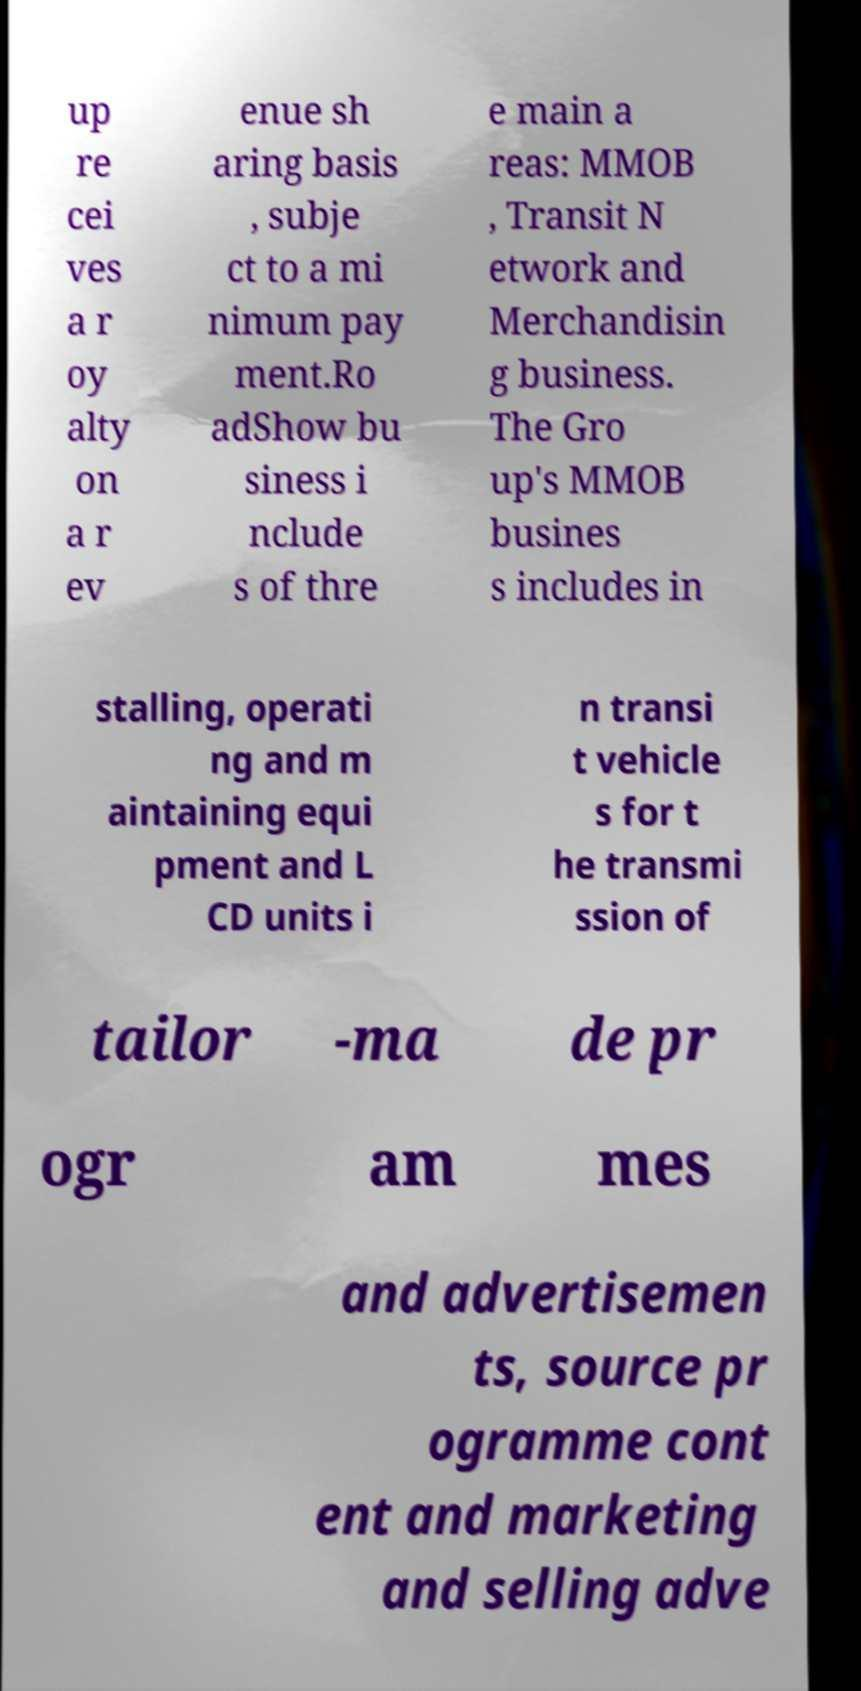Can you read and provide the text displayed in the image?This photo seems to have some interesting text. Can you extract and type it out for me? up re cei ves a r oy alty on a r ev enue sh aring basis , subje ct to a mi nimum pay ment.Ro adShow bu siness i nclude s of thre e main a reas: MMOB , Transit N etwork and Merchandisin g business. The Gro up's MMOB busines s includes in stalling, operati ng and m aintaining equi pment and L CD units i n transi t vehicle s for t he transmi ssion of tailor -ma de pr ogr am mes and advertisemen ts, source pr ogramme cont ent and marketing and selling adve 